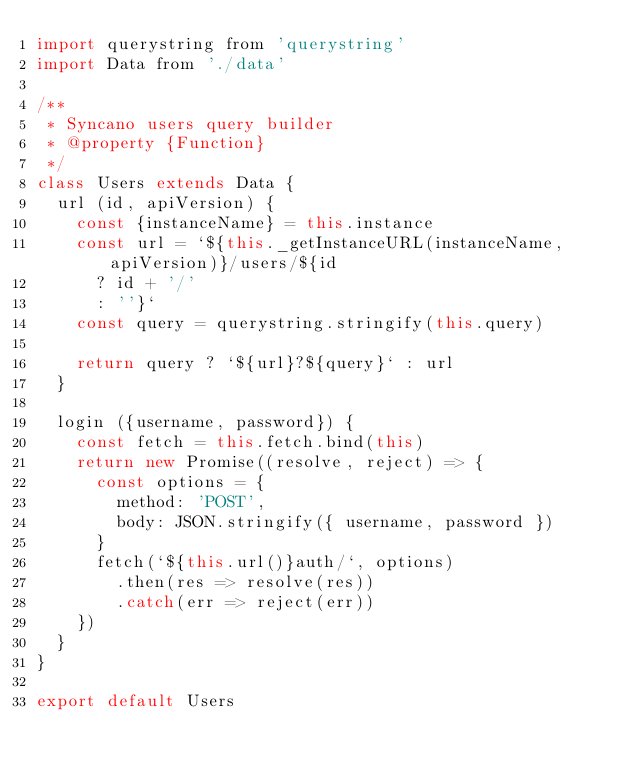Convert code to text. <code><loc_0><loc_0><loc_500><loc_500><_JavaScript_>import querystring from 'querystring'
import Data from './data'

/**
 * Syncano users query builder
 * @property {Function}
 */
class Users extends Data {
  url (id, apiVersion) {
    const {instanceName} = this.instance
    const url = `${this._getInstanceURL(instanceName, apiVersion)}/users/${id
      ? id + '/'
      : ''}`
    const query = querystring.stringify(this.query)

    return query ? `${url}?${query}` : url
  }

  login ({username, password}) {
    const fetch = this.fetch.bind(this)
    return new Promise((resolve, reject) => {
      const options = {
        method: 'POST',
        body: JSON.stringify({ username, password })
      }
      fetch(`${this.url()}auth/`, options)
        .then(res => resolve(res))
        .catch(err => reject(err))
    })
  }
}

export default Users
</code> 